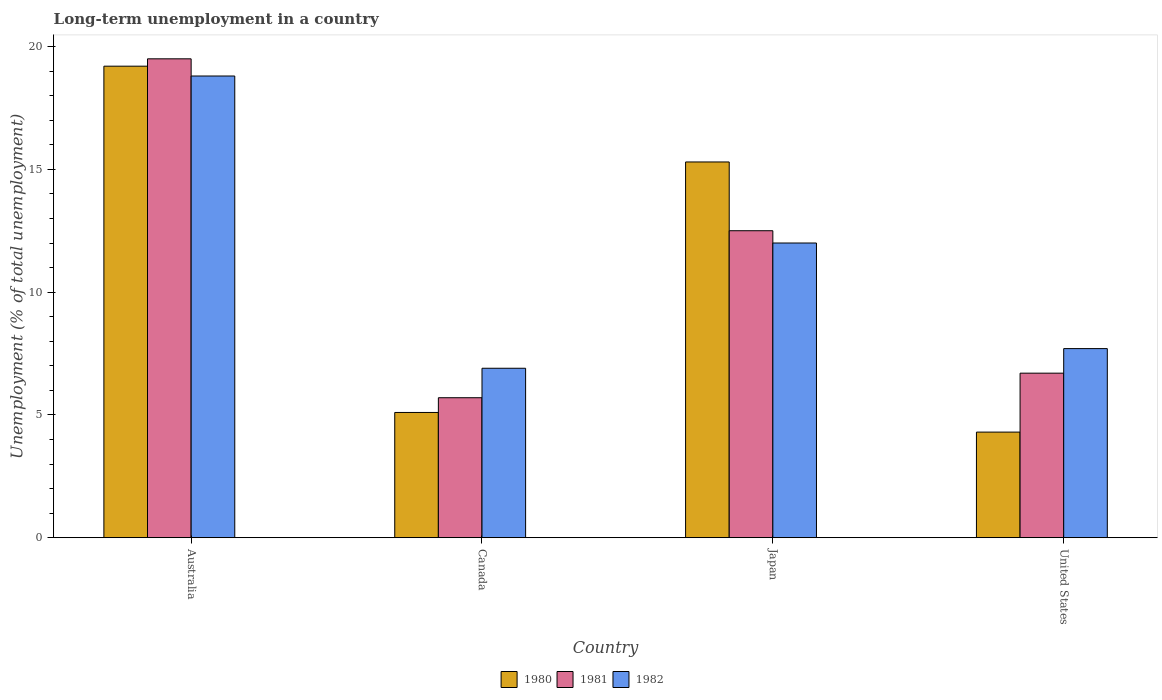How many different coloured bars are there?
Offer a very short reply. 3. Are the number of bars per tick equal to the number of legend labels?
Your response must be concise. Yes. Are the number of bars on each tick of the X-axis equal?
Keep it short and to the point. Yes. How many bars are there on the 4th tick from the left?
Give a very brief answer. 3. How many bars are there on the 2nd tick from the right?
Make the answer very short. 3. What is the percentage of long-term unemployed population in 1980 in Japan?
Ensure brevity in your answer.  15.3. Across all countries, what is the maximum percentage of long-term unemployed population in 1981?
Offer a terse response. 19.5. Across all countries, what is the minimum percentage of long-term unemployed population in 1982?
Ensure brevity in your answer.  6.9. In which country was the percentage of long-term unemployed population in 1982 maximum?
Keep it short and to the point. Australia. In which country was the percentage of long-term unemployed population in 1982 minimum?
Offer a terse response. Canada. What is the total percentage of long-term unemployed population in 1980 in the graph?
Make the answer very short. 43.9. What is the difference between the percentage of long-term unemployed population in 1980 in Japan and the percentage of long-term unemployed population in 1982 in Canada?
Provide a succinct answer. 8.4. What is the average percentage of long-term unemployed population in 1981 per country?
Your answer should be compact. 11.1. In how many countries, is the percentage of long-term unemployed population in 1982 greater than 8 %?
Your answer should be compact. 2. What is the ratio of the percentage of long-term unemployed population in 1982 in Canada to that in Japan?
Give a very brief answer. 0.58. Is the percentage of long-term unemployed population in 1981 in Canada less than that in Japan?
Your answer should be very brief. Yes. Is the difference between the percentage of long-term unemployed population in 1981 in Canada and Japan greater than the difference between the percentage of long-term unemployed population in 1982 in Canada and Japan?
Give a very brief answer. No. What is the difference between the highest and the lowest percentage of long-term unemployed population in 1982?
Offer a very short reply. 11.9. In how many countries, is the percentage of long-term unemployed population in 1982 greater than the average percentage of long-term unemployed population in 1982 taken over all countries?
Provide a succinct answer. 2. Is the sum of the percentage of long-term unemployed population in 1980 in Canada and Japan greater than the maximum percentage of long-term unemployed population in 1981 across all countries?
Provide a short and direct response. Yes. What does the 3rd bar from the left in Canada represents?
Make the answer very short. 1982. What does the 3rd bar from the right in United States represents?
Your answer should be compact. 1980. Is it the case that in every country, the sum of the percentage of long-term unemployed population in 1980 and percentage of long-term unemployed population in 1982 is greater than the percentage of long-term unemployed population in 1981?
Offer a terse response. Yes. How many bars are there?
Ensure brevity in your answer.  12. Are all the bars in the graph horizontal?
Your answer should be very brief. No. Does the graph contain any zero values?
Offer a very short reply. No. Does the graph contain grids?
Give a very brief answer. No. How are the legend labels stacked?
Make the answer very short. Horizontal. What is the title of the graph?
Keep it short and to the point. Long-term unemployment in a country. What is the label or title of the X-axis?
Make the answer very short. Country. What is the label or title of the Y-axis?
Provide a succinct answer. Unemployment (% of total unemployment). What is the Unemployment (% of total unemployment) of 1980 in Australia?
Make the answer very short. 19.2. What is the Unemployment (% of total unemployment) in 1981 in Australia?
Keep it short and to the point. 19.5. What is the Unemployment (% of total unemployment) of 1982 in Australia?
Provide a short and direct response. 18.8. What is the Unemployment (% of total unemployment) of 1980 in Canada?
Give a very brief answer. 5.1. What is the Unemployment (% of total unemployment) of 1981 in Canada?
Ensure brevity in your answer.  5.7. What is the Unemployment (% of total unemployment) of 1982 in Canada?
Your answer should be compact. 6.9. What is the Unemployment (% of total unemployment) in 1980 in Japan?
Your answer should be compact. 15.3. What is the Unemployment (% of total unemployment) in 1980 in United States?
Provide a succinct answer. 4.3. What is the Unemployment (% of total unemployment) in 1981 in United States?
Give a very brief answer. 6.7. What is the Unemployment (% of total unemployment) in 1982 in United States?
Offer a very short reply. 7.7. Across all countries, what is the maximum Unemployment (% of total unemployment) of 1980?
Your response must be concise. 19.2. Across all countries, what is the maximum Unemployment (% of total unemployment) of 1981?
Your response must be concise. 19.5. Across all countries, what is the maximum Unemployment (% of total unemployment) in 1982?
Ensure brevity in your answer.  18.8. Across all countries, what is the minimum Unemployment (% of total unemployment) of 1980?
Make the answer very short. 4.3. Across all countries, what is the minimum Unemployment (% of total unemployment) of 1981?
Ensure brevity in your answer.  5.7. Across all countries, what is the minimum Unemployment (% of total unemployment) in 1982?
Give a very brief answer. 6.9. What is the total Unemployment (% of total unemployment) of 1980 in the graph?
Provide a short and direct response. 43.9. What is the total Unemployment (% of total unemployment) of 1981 in the graph?
Your answer should be very brief. 44.4. What is the total Unemployment (% of total unemployment) of 1982 in the graph?
Your answer should be very brief. 45.4. What is the difference between the Unemployment (% of total unemployment) of 1981 in Australia and that in Canada?
Your answer should be very brief. 13.8. What is the difference between the Unemployment (% of total unemployment) in 1982 in Australia and that in Canada?
Keep it short and to the point. 11.9. What is the difference between the Unemployment (% of total unemployment) of 1980 in Australia and that in Japan?
Your answer should be very brief. 3.9. What is the difference between the Unemployment (% of total unemployment) in 1981 in Australia and that in Japan?
Your answer should be very brief. 7. What is the difference between the Unemployment (% of total unemployment) of 1982 in Australia and that in Japan?
Ensure brevity in your answer.  6.8. What is the difference between the Unemployment (% of total unemployment) in 1980 in Australia and that in United States?
Make the answer very short. 14.9. What is the difference between the Unemployment (% of total unemployment) in 1981 in Australia and that in United States?
Offer a very short reply. 12.8. What is the difference between the Unemployment (% of total unemployment) in 1982 in Australia and that in United States?
Your answer should be compact. 11.1. What is the difference between the Unemployment (% of total unemployment) of 1980 in Canada and that in Japan?
Keep it short and to the point. -10.2. What is the difference between the Unemployment (% of total unemployment) of 1982 in Canada and that in Japan?
Give a very brief answer. -5.1. What is the difference between the Unemployment (% of total unemployment) in 1982 in Canada and that in United States?
Provide a succinct answer. -0.8. What is the difference between the Unemployment (% of total unemployment) of 1981 in Japan and that in United States?
Provide a succinct answer. 5.8. What is the difference between the Unemployment (% of total unemployment) of 1982 in Japan and that in United States?
Offer a terse response. 4.3. What is the difference between the Unemployment (% of total unemployment) in 1980 in Australia and the Unemployment (% of total unemployment) in 1981 in Canada?
Provide a short and direct response. 13.5. What is the difference between the Unemployment (% of total unemployment) in 1980 in Australia and the Unemployment (% of total unemployment) in 1982 in Canada?
Give a very brief answer. 12.3. What is the difference between the Unemployment (% of total unemployment) of 1981 in Australia and the Unemployment (% of total unemployment) of 1982 in Canada?
Your answer should be compact. 12.6. What is the difference between the Unemployment (% of total unemployment) in 1980 in Australia and the Unemployment (% of total unemployment) in 1981 in Japan?
Offer a terse response. 6.7. What is the difference between the Unemployment (% of total unemployment) in 1980 in Australia and the Unemployment (% of total unemployment) in 1982 in Japan?
Ensure brevity in your answer.  7.2. What is the difference between the Unemployment (% of total unemployment) in 1981 in Australia and the Unemployment (% of total unemployment) in 1982 in Japan?
Your answer should be very brief. 7.5. What is the difference between the Unemployment (% of total unemployment) in 1980 in Australia and the Unemployment (% of total unemployment) in 1981 in United States?
Give a very brief answer. 12.5. What is the difference between the Unemployment (% of total unemployment) in 1980 in Australia and the Unemployment (% of total unemployment) in 1982 in United States?
Ensure brevity in your answer.  11.5. What is the difference between the Unemployment (% of total unemployment) of 1981 in Australia and the Unemployment (% of total unemployment) of 1982 in United States?
Keep it short and to the point. 11.8. What is the difference between the Unemployment (% of total unemployment) in 1981 in Canada and the Unemployment (% of total unemployment) in 1982 in Japan?
Your answer should be compact. -6.3. What is the difference between the Unemployment (% of total unemployment) in 1980 in Canada and the Unemployment (% of total unemployment) in 1982 in United States?
Your response must be concise. -2.6. What is the difference between the Unemployment (% of total unemployment) in 1980 in Japan and the Unemployment (% of total unemployment) in 1981 in United States?
Make the answer very short. 8.6. What is the difference between the Unemployment (% of total unemployment) of 1980 in Japan and the Unemployment (% of total unemployment) of 1982 in United States?
Provide a short and direct response. 7.6. What is the difference between the Unemployment (% of total unemployment) in 1981 in Japan and the Unemployment (% of total unemployment) in 1982 in United States?
Offer a very short reply. 4.8. What is the average Unemployment (% of total unemployment) in 1980 per country?
Keep it short and to the point. 10.97. What is the average Unemployment (% of total unemployment) in 1981 per country?
Provide a succinct answer. 11.1. What is the average Unemployment (% of total unemployment) of 1982 per country?
Provide a succinct answer. 11.35. What is the difference between the Unemployment (% of total unemployment) in 1980 and Unemployment (% of total unemployment) in 1981 in Australia?
Your response must be concise. -0.3. What is the difference between the Unemployment (% of total unemployment) of 1980 and Unemployment (% of total unemployment) of 1981 in Canada?
Provide a succinct answer. -0.6. What is the difference between the Unemployment (% of total unemployment) of 1980 and Unemployment (% of total unemployment) of 1982 in Canada?
Provide a short and direct response. -1.8. What is the difference between the Unemployment (% of total unemployment) in 1981 and Unemployment (% of total unemployment) in 1982 in Canada?
Provide a succinct answer. -1.2. What is the difference between the Unemployment (% of total unemployment) in 1980 and Unemployment (% of total unemployment) in 1981 in Japan?
Give a very brief answer. 2.8. What is the difference between the Unemployment (% of total unemployment) of 1981 and Unemployment (% of total unemployment) of 1982 in Japan?
Your answer should be very brief. 0.5. What is the difference between the Unemployment (% of total unemployment) of 1980 and Unemployment (% of total unemployment) of 1982 in United States?
Provide a succinct answer. -3.4. What is the ratio of the Unemployment (% of total unemployment) of 1980 in Australia to that in Canada?
Your answer should be compact. 3.76. What is the ratio of the Unemployment (% of total unemployment) in 1981 in Australia to that in Canada?
Make the answer very short. 3.42. What is the ratio of the Unemployment (% of total unemployment) in 1982 in Australia to that in Canada?
Give a very brief answer. 2.72. What is the ratio of the Unemployment (% of total unemployment) in 1980 in Australia to that in Japan?
Your answer should be very brief. 1.25. What is the ratio of the Unemployment (% of total unemployment) of 1981 in Australia to that in Japan?
Your answer should be compact. 1.56. What is the ratio of the Unemployment (% of total unemployment) of 1982 in Australia to that in Japan?
Your answer should be compact. 1.57. What is the ratio of the Unemployment (% of total unemployment) of 1980 in Australia to that in United States?
Offer a terse response. 4.47. What is the ratio of the Unemployment (% of total unemployment) of 1981 in Australia to that in United States?
Your response must be concise. 2.91. What is the ratio of the Unemployment (% of total unemployment) of 1982 in Australia to that in United States?
Make the answer very short. 2.44. What is the ratio of the Unemployment (% of total unemployment) of 1980 in Canada to that in Japan?
Provide a short and direct response. 0.33. What is the ratio of the Unemployment (% of total unemployment) of 1981 in Canada to that in Japan?
Give a very brief answer. 0.46. What is the ratio of the Unemployment (% of total unemployment) of 1982 in Canada to that in Japan?
Provide a succinct answer. 0.57. What is the ratio of the Unemployment (% of total unemployment) of 1980 in Canada to that in United States?
Offer a very short reply. 1.19. What is the ratio of the Unemployment (% of total unemployment) of 1981 in Canada to that in United States?
Your response must be concise. 0.85. What is the ratio of the Unemployment (% of total unemployment) of 1982 in Canada to that in United States?
Your answer should be compact. 0.9. What is the ratio of the Unemployment (% of total unemployment) in 1980 in Japan to that in United States?
Offer a very short reply. 3.56. What is the ratio of the Unemployment (% of total unemployment) in 1981 in Japan to that in United States?
Provide a succinct answer. 1.87. What is the ratio of the Unemployment (% of total unemployment) of 1982 in Japan to that in United States?
Offer a very short reply. 1.56. What is the difference between the highest and the second highest Unemployment (% of total unemployment) of 1982?
Make the answer very short. 6.8. What is the difference between the highest and the lowest Unemployment (% of total unemployment) of 1981?
Provide a short and direct response. 13.8. What is the difference between the highest and the lowest Unemployment (% of total unemployment) in 1982?
Provide a short and direct response. 11.9. 